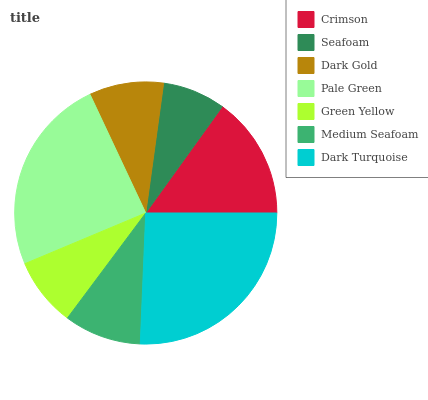Is Seafoam the minimum?
Answer yes or no. Yes. Is Dark Turquoise the maximum?
Answer yes or no. Yes. Is Dark Gold the minimum?
Answer yes or no. No. Is Dark Gold the maximum?
Answer yes or no. No. Is Dark Gold greater than Seafoam?
Answer yes or no. Yes. Is Seafoam less than Dark Gold?
Answer yes or no. Yes. Is Seafoam greater than Dark Gold?
Answer yes or no. No. Is Dark Gold less than Seafoam?
Answer yes or no. No. Is Medium Seafoam the high median?
Answer yes or no. Yes. Is Medium Seafoam the low median?
Answer yes or no. Yes. Is Crimson the high median?
Answer yes or no. No. Is Dark Turquoise the low median?
Answer yes or no. No. 